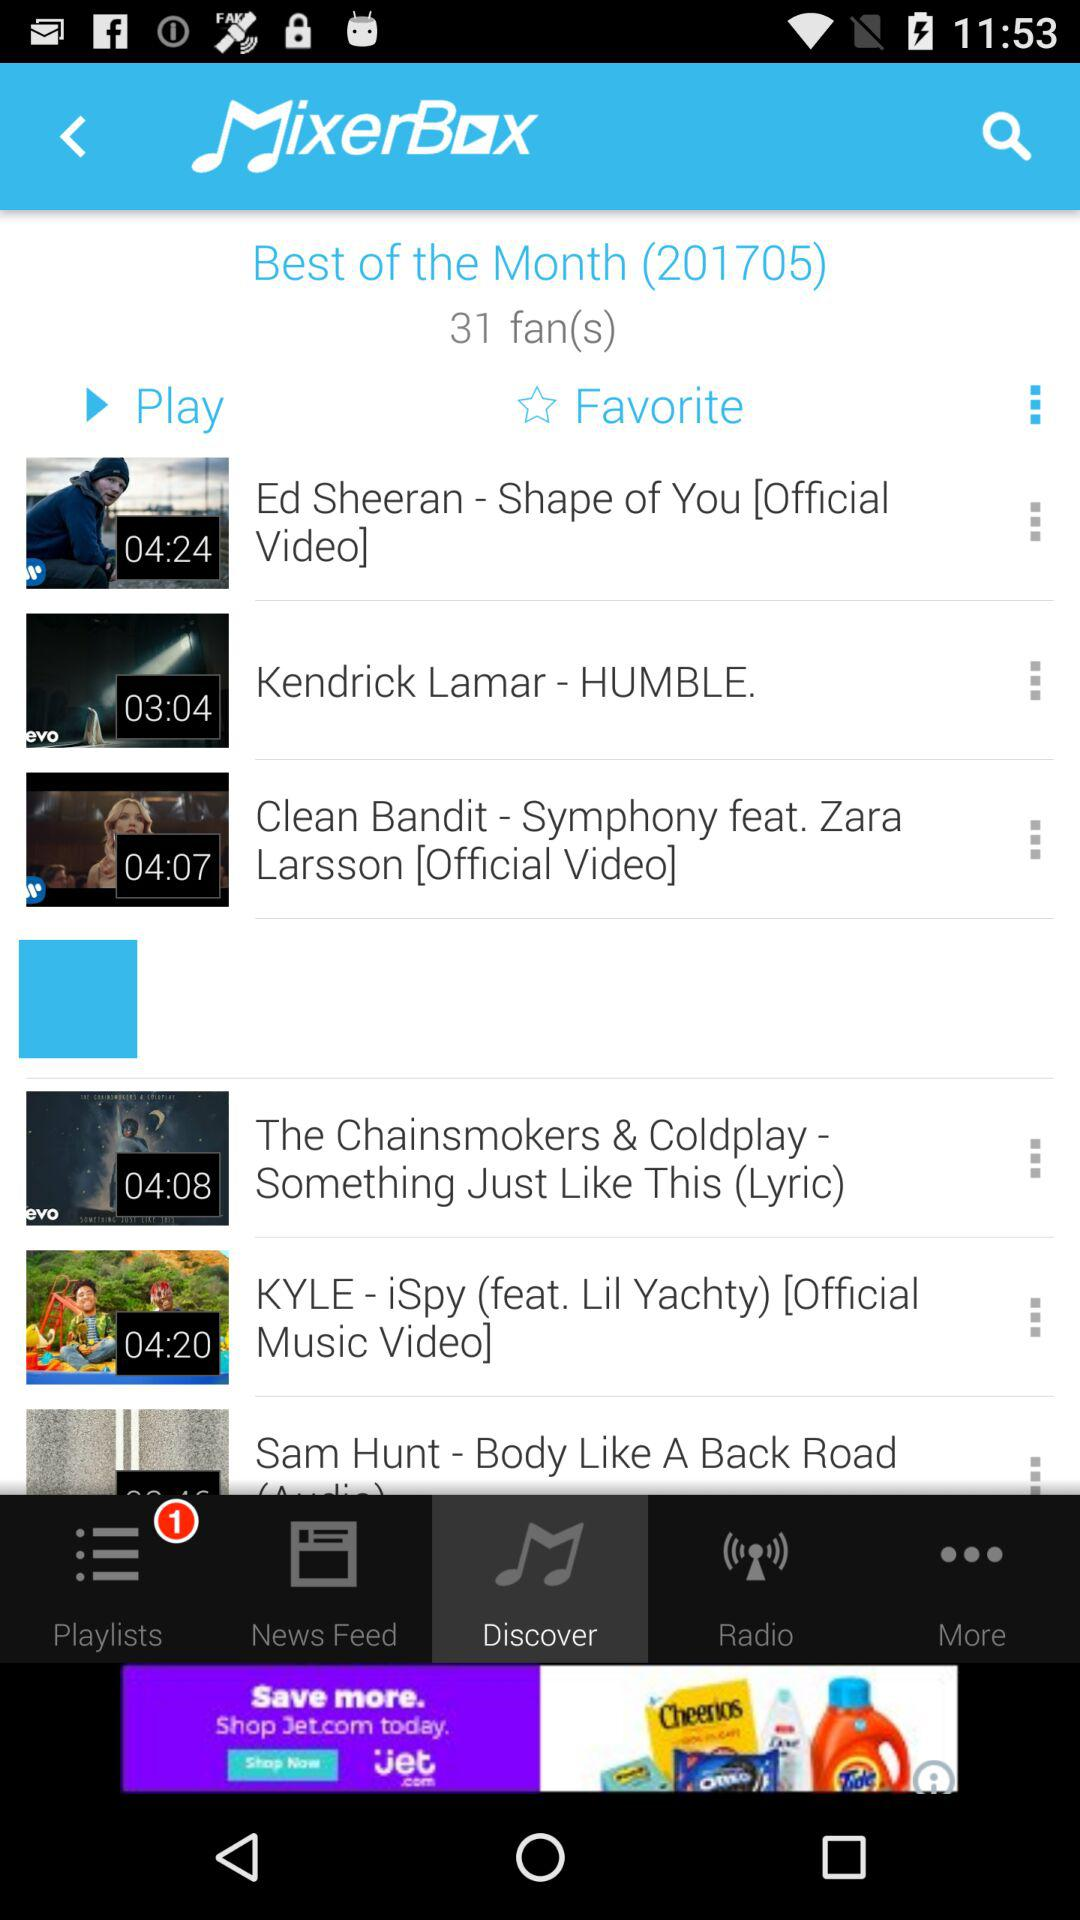What is the time duration of the "Shape of You" song? The time duration of the "Shape of You" song is 4 minutes 24 seconds. 